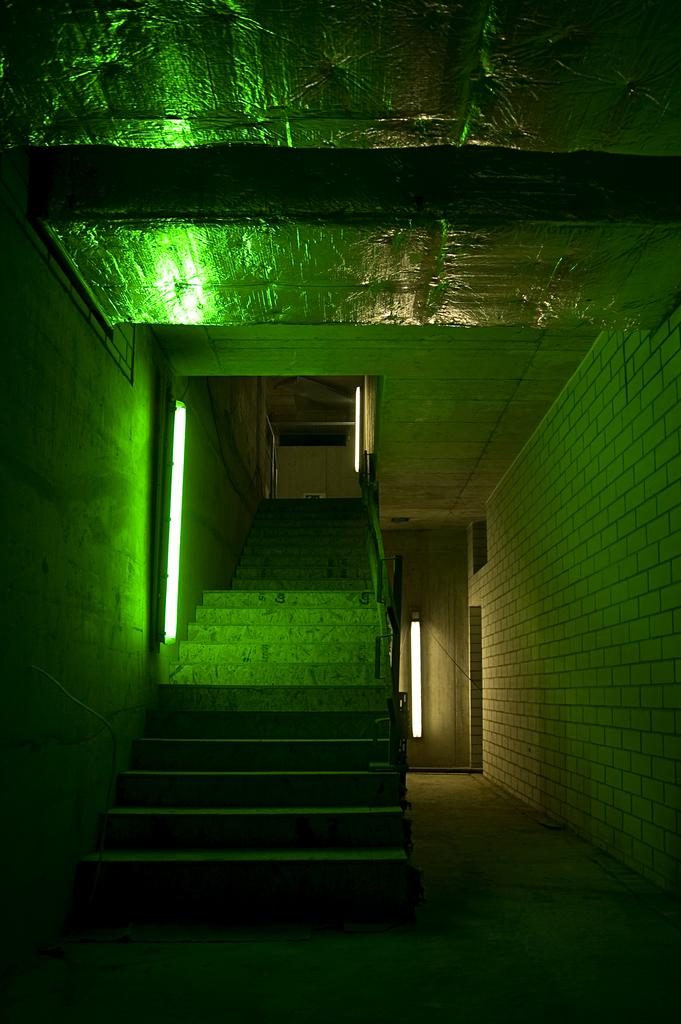What is the main subject of the image? The main subject of the image is an inside view of stairs. Can you describe any lighting in the image? Yes, there is a green color light beside the stairs. What is located behind the stairs? There is a white door behind the stairs. What material is used for the ceiling in the image? The ceiling has an aluminium foil roofing. What type of power station can be seen in the image? There is no power station present in the image; it shows an inside view of stairs with a green light, a white door, and an aluminium foil roofing. 